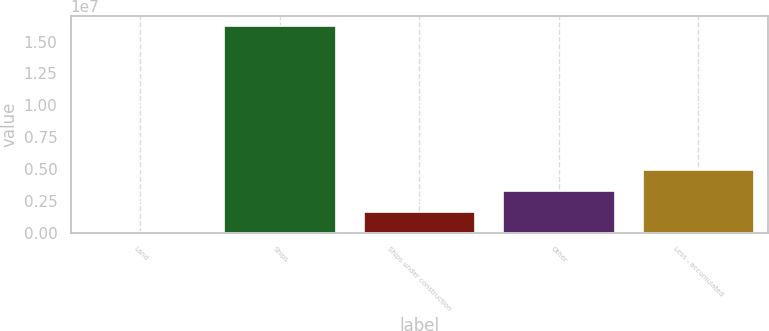<chart> <loc_0><loc_0><loc_500><loc_500><bar_chart><fcel>Land<fcel>Ships<fcel>Ships under construction<fcel>Other<fcel>Less - accumulated<nl><fcel>16288<fcel>1.62148e+07<fcel>1.63614e+06<fcel>3.256e+06<fcel>4.87585e+06<nl></chart> 